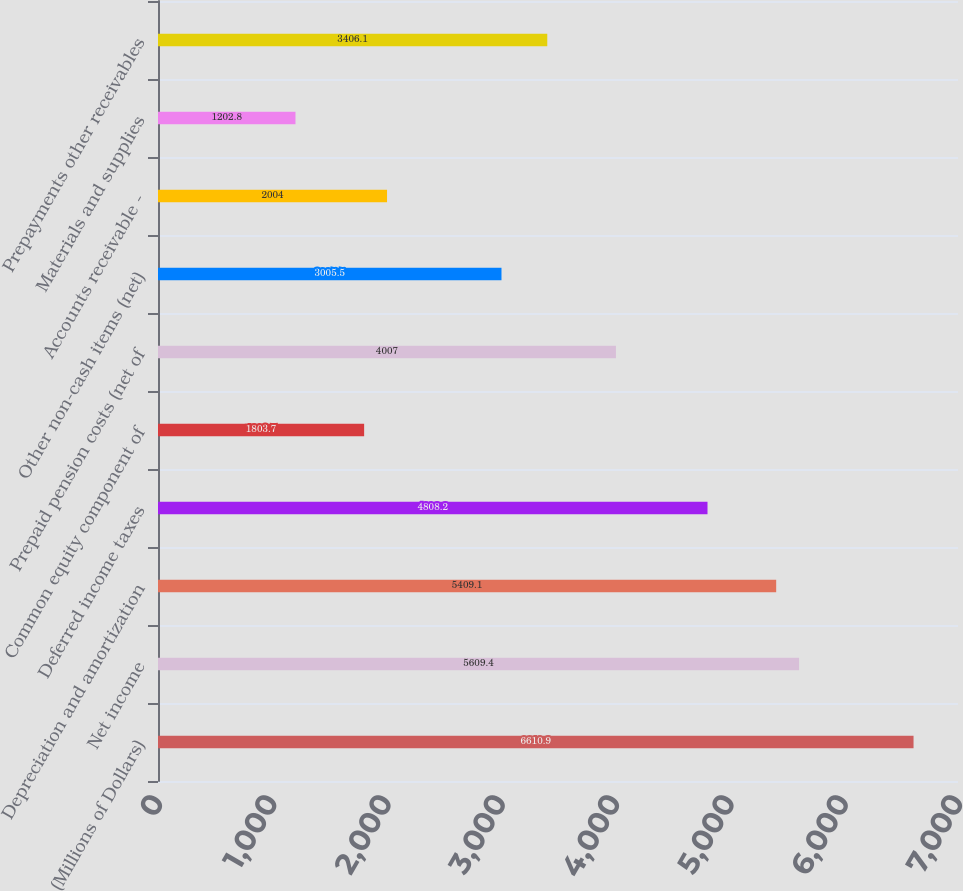Convert chart to OTSL. <chart><loc_0><loc_0><loc_500><loc_500><bar_chart><fcel>(Millions of Dollars)<fcel>Net income<fcel>Depreciation and amortization<fcel>Deferred income taxes<fcel>Common equity component of<fcel>Prepaid pension costs (net of<fcel>Other non-cash items (net)<fcel>Accounts receivable -<fcel>Materials and supplies<fcel>Prepayments other receivables<nl><fcel>6610.9<fcel>5609.4<fcel>5409.1<fcel>4808.2<fcel>1803.7<fcel>4007<fcel>3005.5<fcel>2004<fcel>1202.8<fcel>3406.1<nl></chart> 